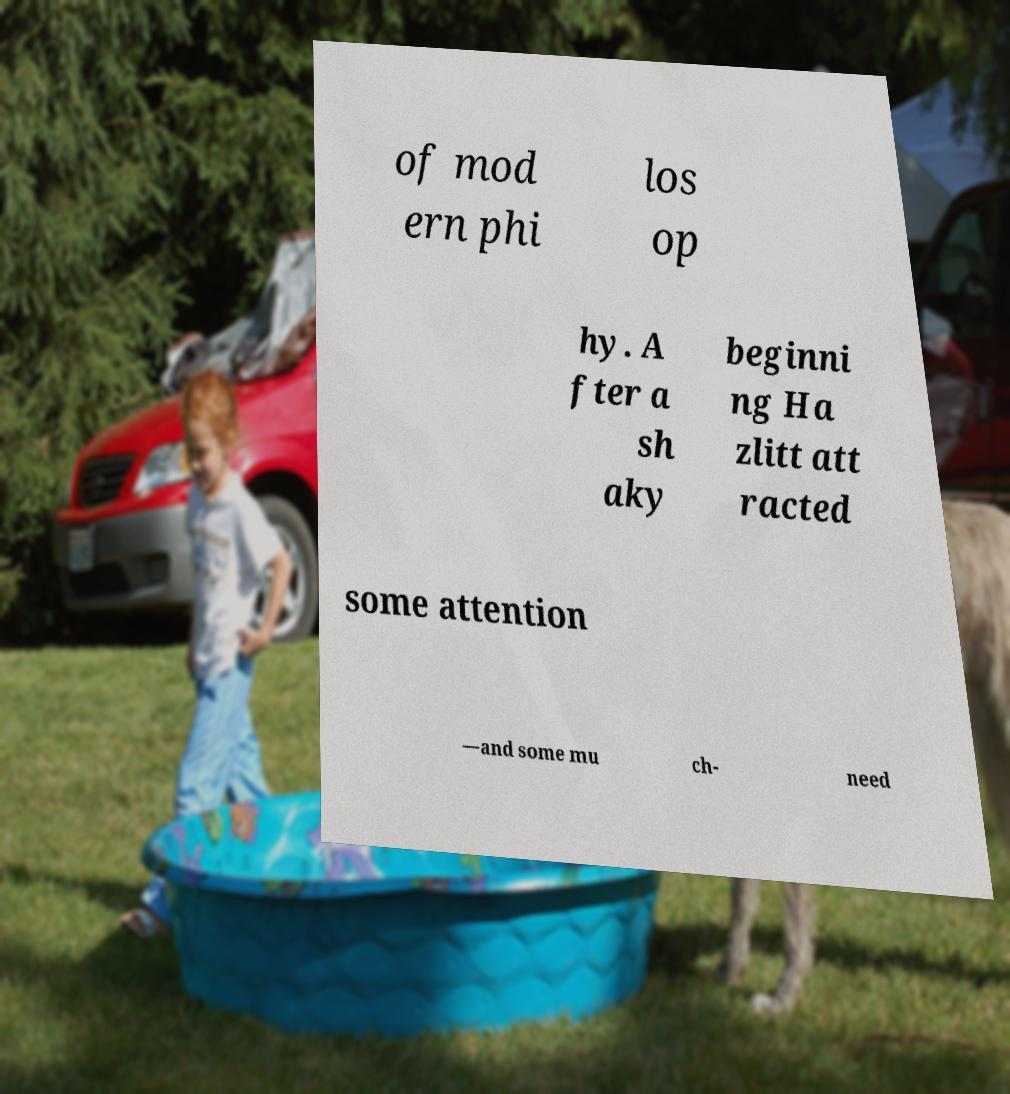For documentation purposes, I need the text within this image transcribed. Could you provide that? of mod ern phi los op hy. A fter a sh aky beginni ng Ha zlitt att racted some attention —and some mu ch- need 